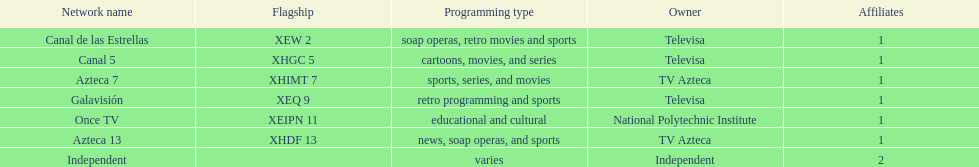Which owner only owns one network? National Polytechnic Institute, Independent. Of those, what is the network name? Once TV, Independent. Of those, which programming type is educational and cultural? Once TV. 